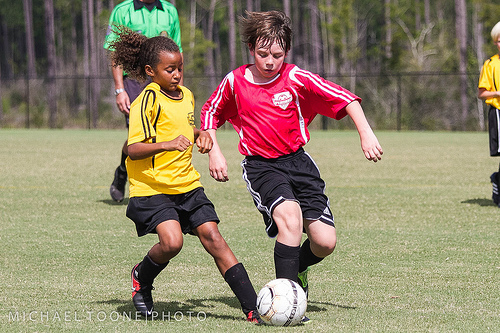<image>
Can you confirm if the red boy is to the left of the yellow boy? Yes. From this viewpoint, the red boy is positioned to the left side relative to the yellow boy. Where is the boy in relation to the girl? Is it to the left of the girl? Yes. From this viewpoint, the boy is positioned to the left side relative to the girl. Is there a blond hair to the right of the green shirt? Yes. From this viewpoint, the blond hair is positioned to the right side relative to the green shirt. 